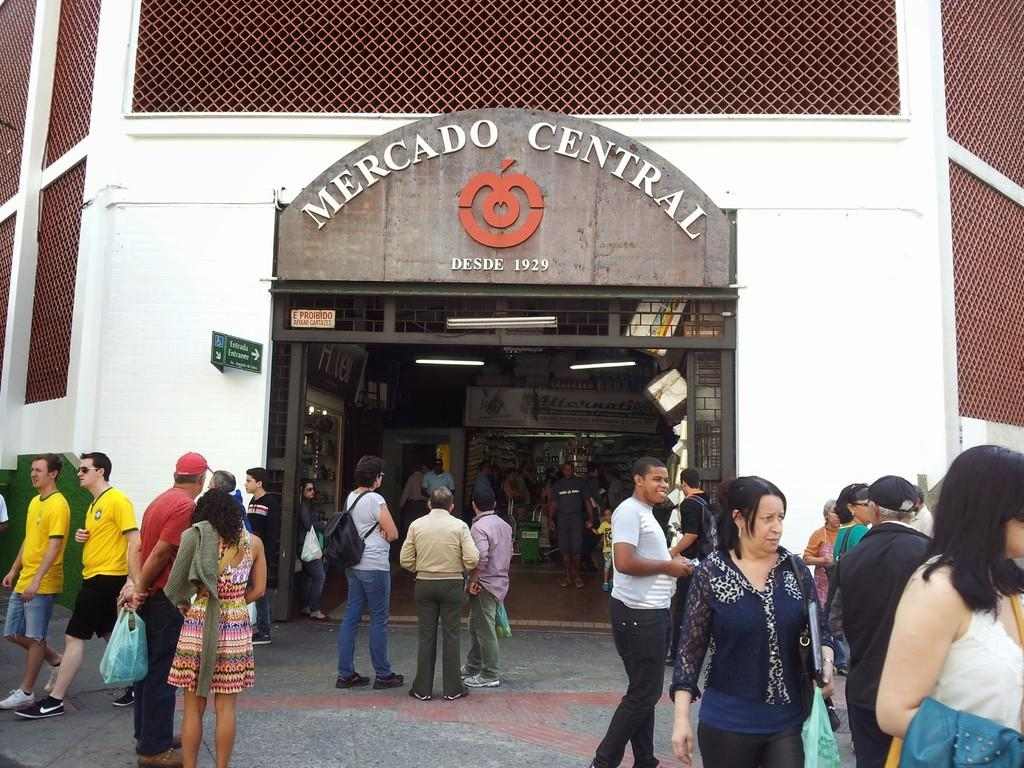<image>
Summarize the visual content of the image. several groups of people gathered and talking in front of Mercado Central building 